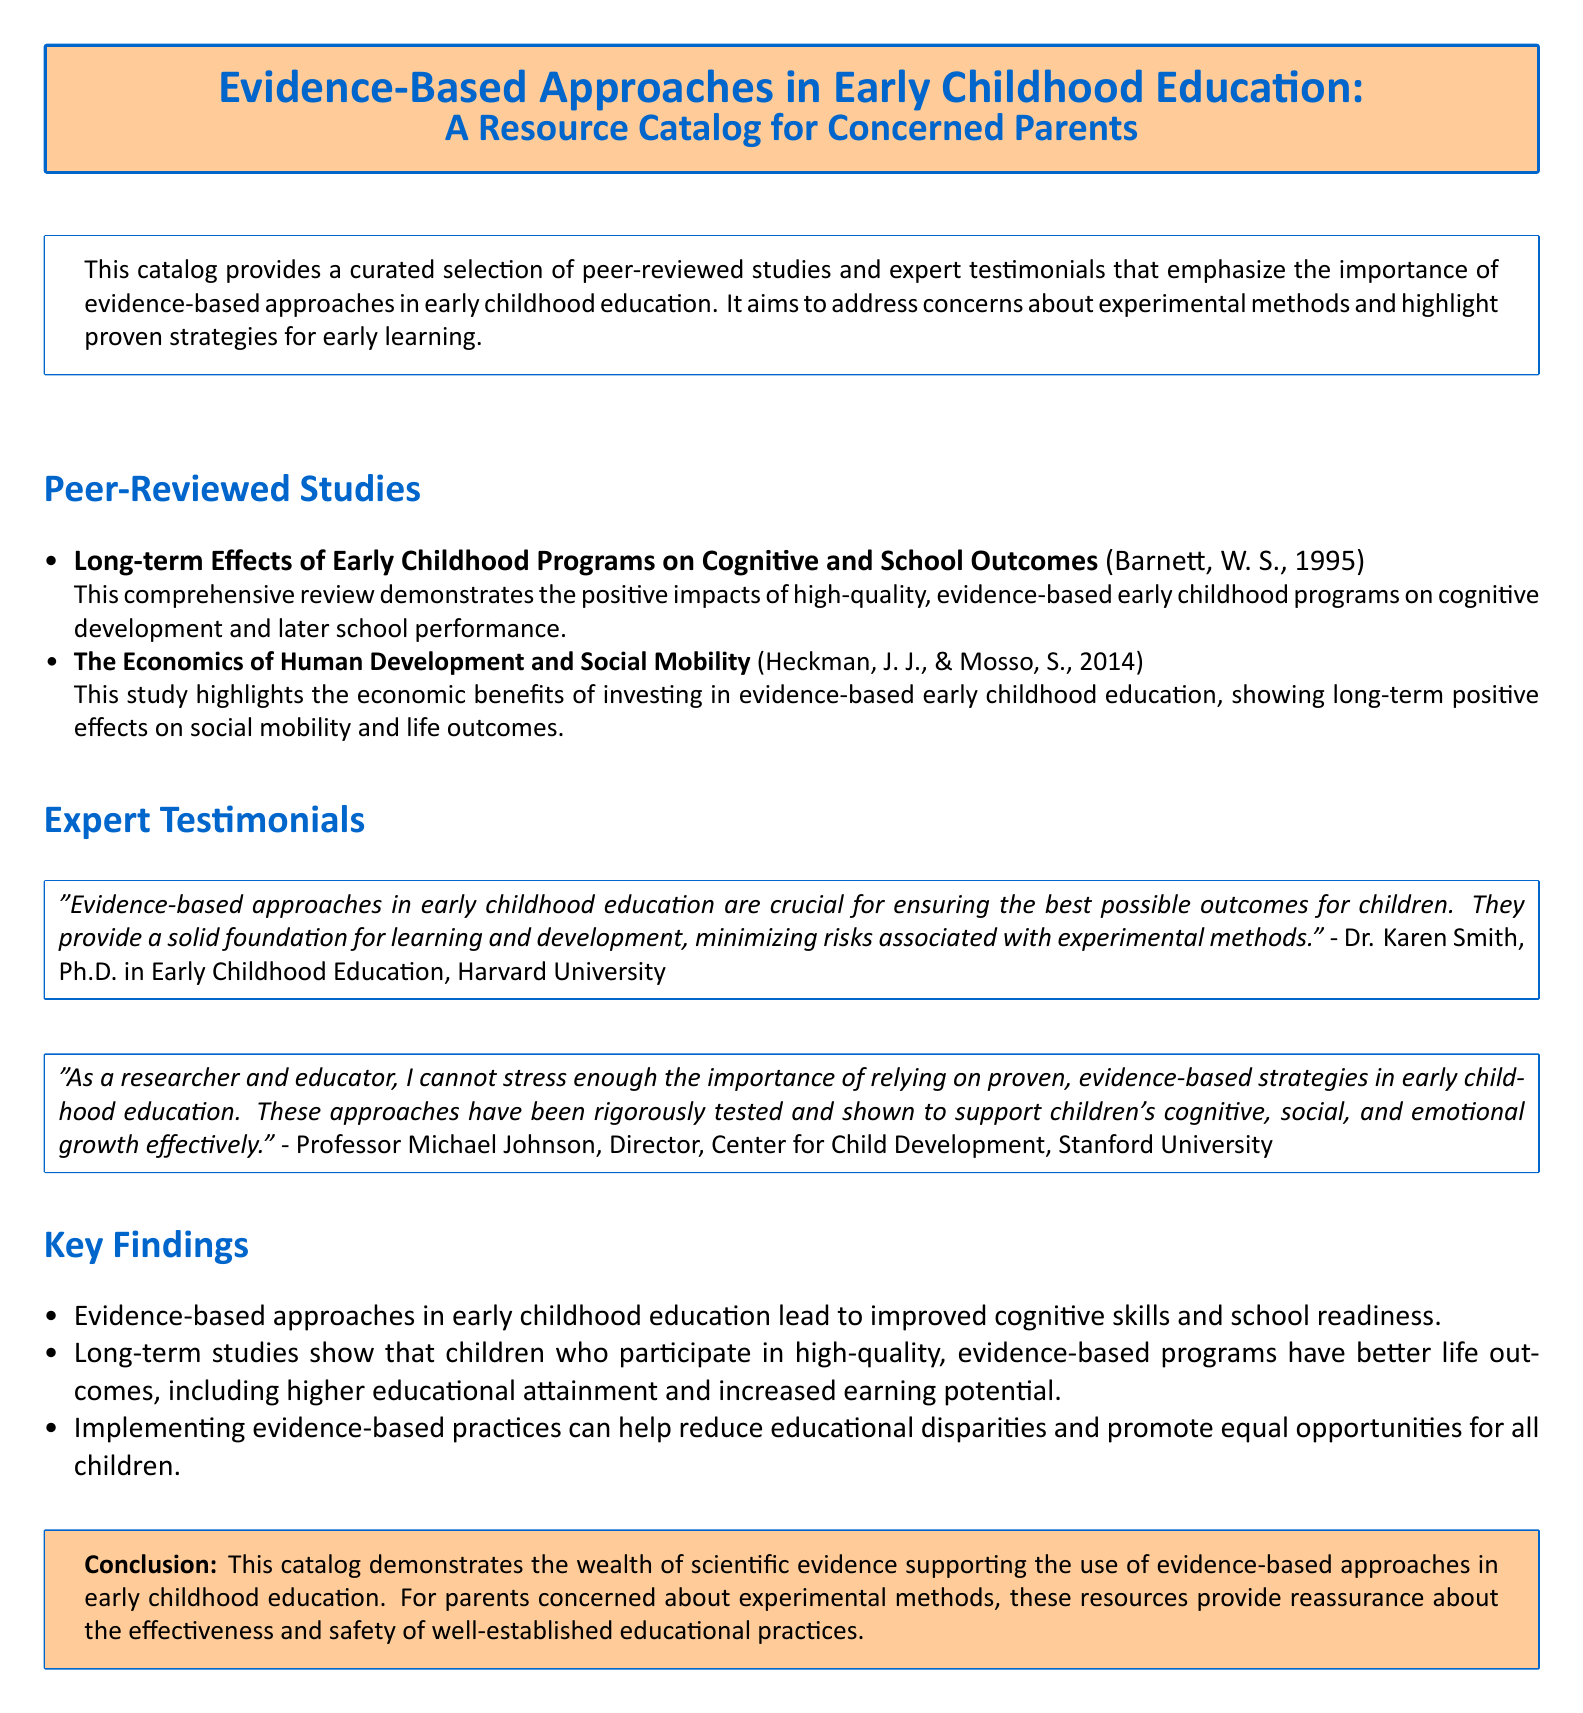What is the title of the resource catalog? The title is prominently displayed and reflects the content focus on evidence-based approaches in early childhood education.
Answer: Evidence-Based Approaches in Early Childhood Education: A Resource Catalog for Concerned Parents Who authored the study on long-term effects of early childhood programs? The document lists specific authors for each study, allowing for easy identification of contributors.
Answer: Barnett, W. S What is one key finding mentioned in the catalog? The key findings summarize the benefits supported by evidence-based approaches in early childhood education, featuring various aspects.
Answer: Improved cognitive skills and school readiness Which expert emphasized the importance of evidence-based strategies? Expert testimonials provide credible opinions regarding the practices discussed in the catalog.
Answer: Dr. Karen Smith How many peer-reviewed studies are listed in the document? The document presents a straightforward count of entries in the peer-reviewed studies section.
Answer: Two What institution is Dr. Karen Smith affiliated with? The affiliations of experts give context to their credibility and authority on the subject matter.
Answer: Harvard University What year was the study on The Economics of Human Development published? Specific publication years are included to contextualize the timeliness of the research presented.
Answer: 2014 What is one outcome of high-quality, evidence-based early childhood programs? Outcomes provide insight into the long-term impacts of educational approaches discussed in the resource.
Answer: Better life outcomes 